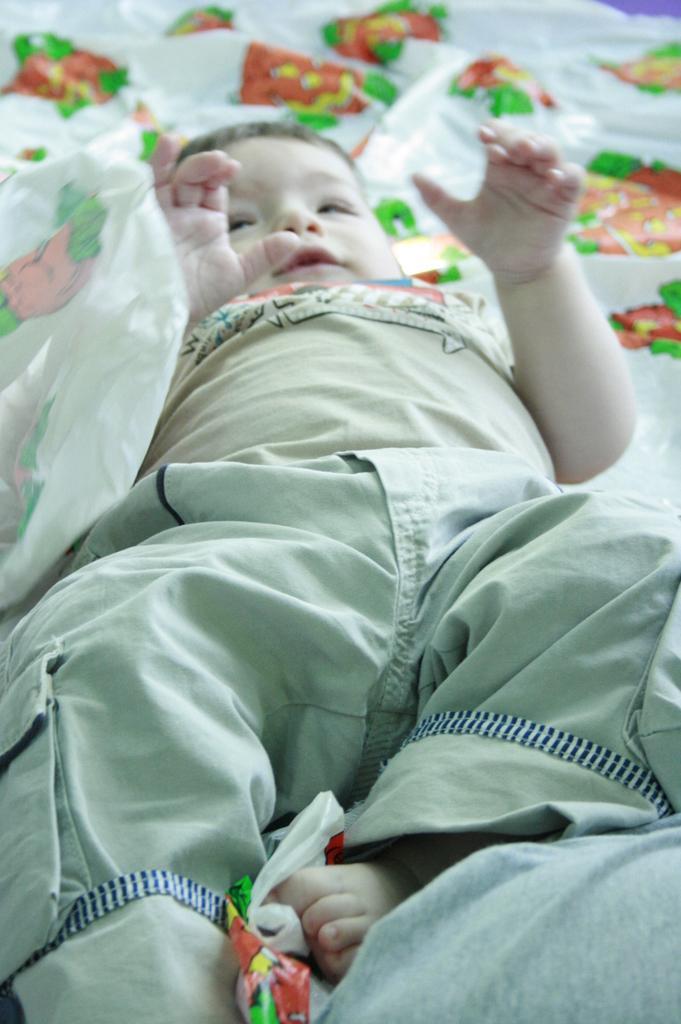In one or two sentences, can you explain what this image depicts? In the center of the image a kid is lying on a bed. In the background of the image we can see some plastic papers are there. 